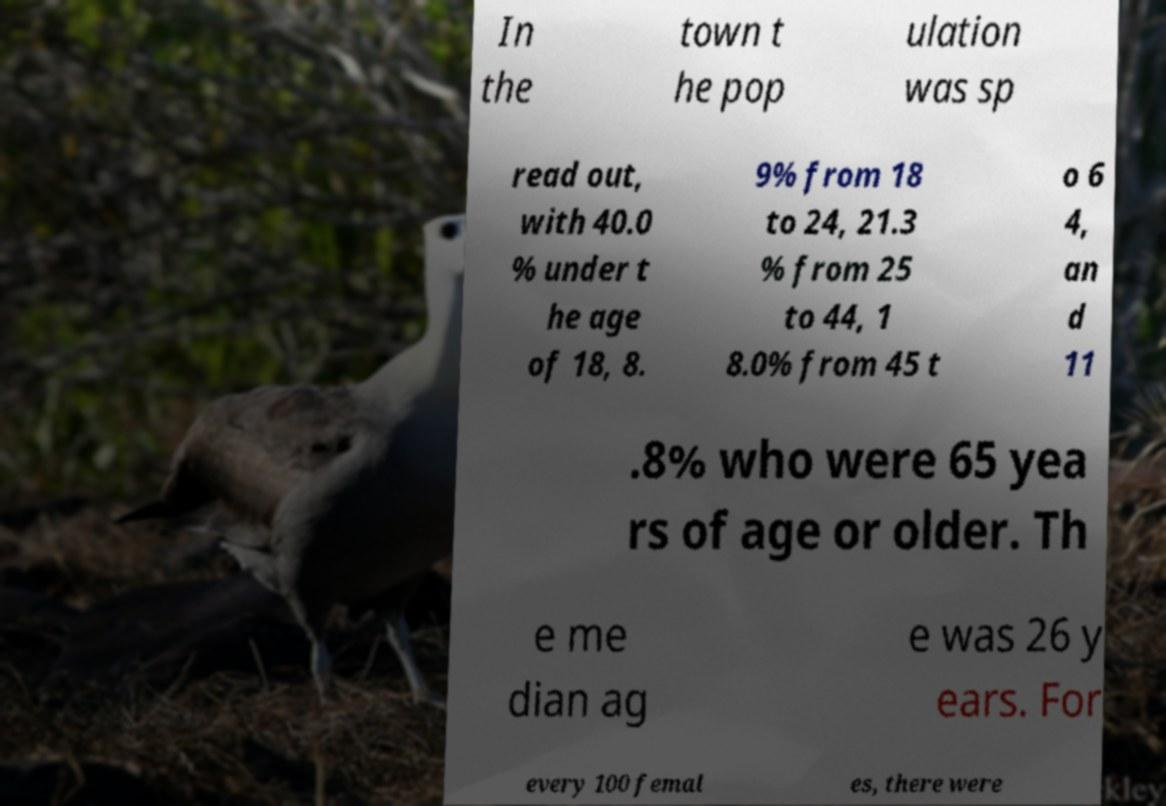I need the written content from this picture converted into text. Can you do that? In the town t he pop ulation was sp read out, with 40.0 % under t he age of 18, 8. 9% from 18 to 24, 21.3 % from 25 to 44, 1 8.0% from 45 t o 6 4, an d 11 .8% who were 65 yea rs of age or older. Th e me dian ag e was 26 y ears. For every 100 femal es, there were 